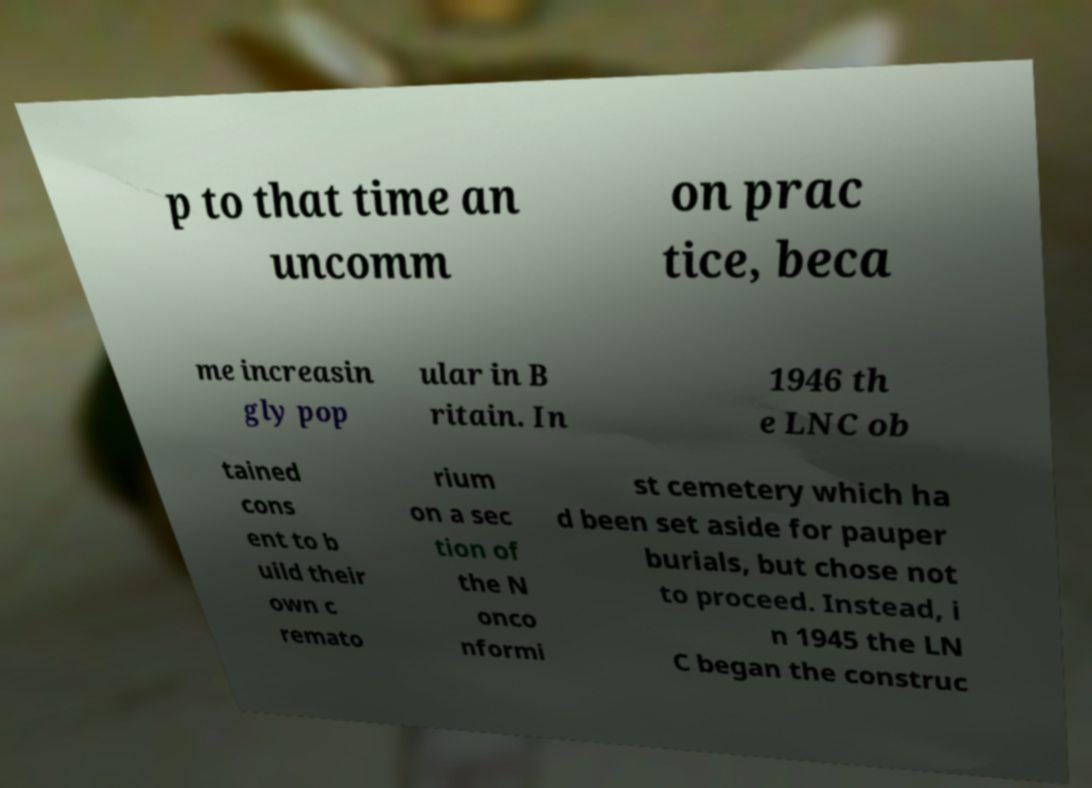Please identify and transcribe the text found in this image. p to that time an uncomm on prac tice, beca me increasin gly pop ular in B ritain. In 1946 th e LNC ob tained cons ent to b uild their own c remato rium on a sec tion of the N onco nformi st cemetery which ha d been set aside for pauper burials, but chose not to proceed. Instead, i n 1945 the LN C began the construc 